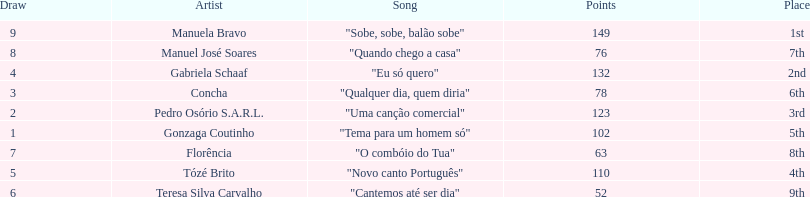Who scored the most points? Manuela Bravo. 